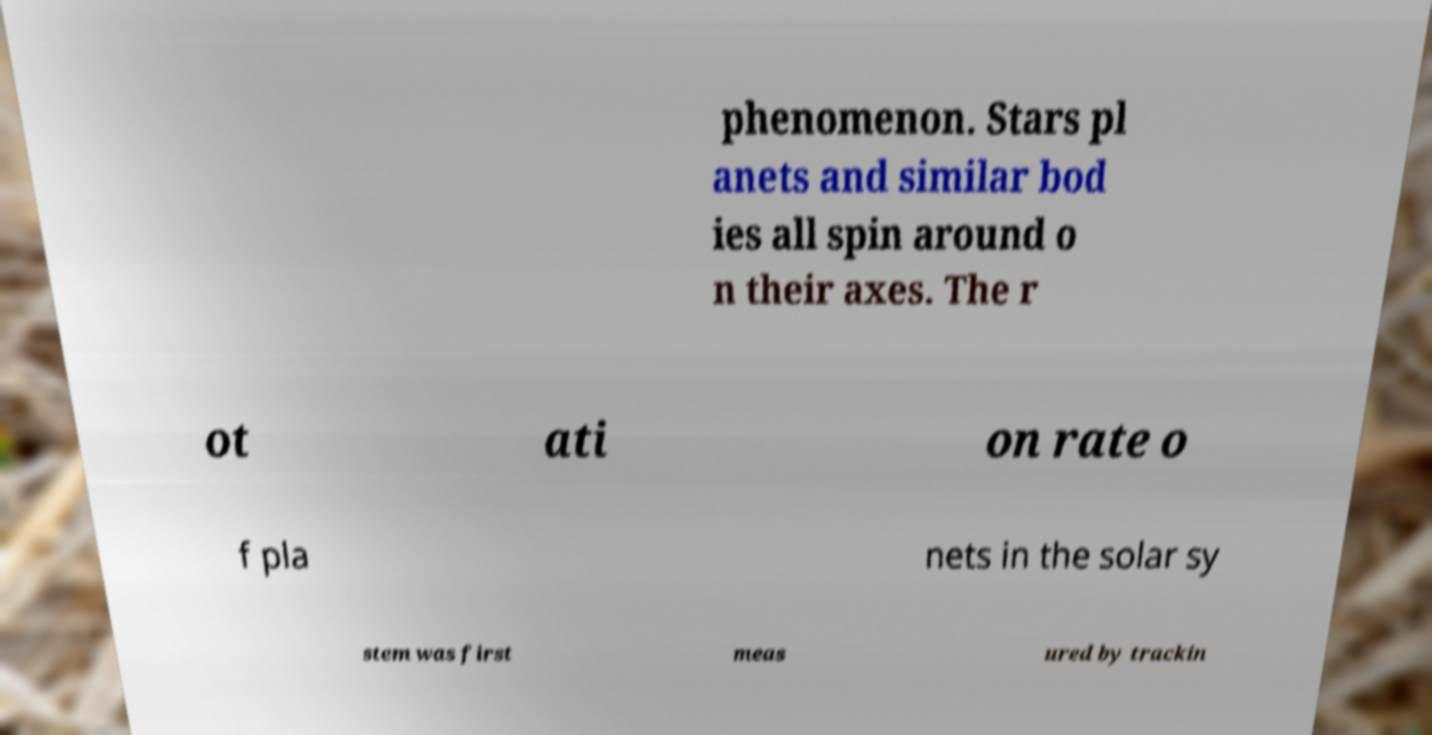There's text embedded in this image that I need extracted. Can you transcribe it verbatim? phenomenon. Stars pl anets and similar bod ies all spin around o n their axes. The r ot ati on rate o f pla nets in the solar sy stem was first meas ured by trackin 